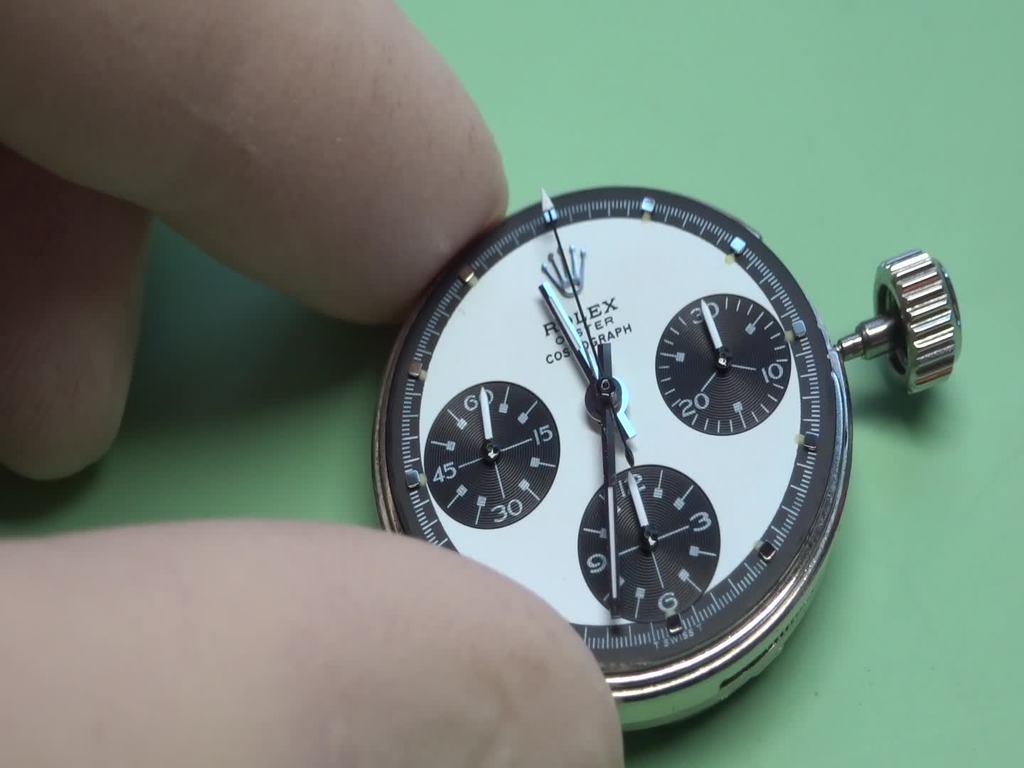What brand is the watch?
Ensure brevity in your answer.  Rolex. What brand of watch is this?
Offer a very short reply. Rolex. 